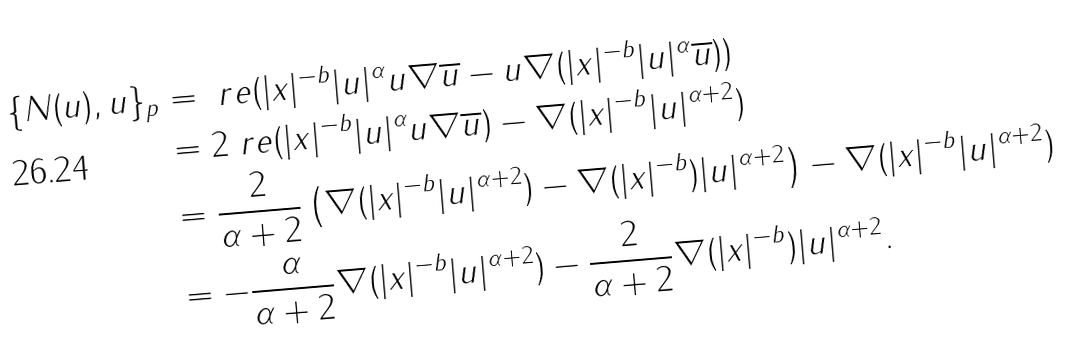<formula> <loc_0><loc_0><loc_500><loc_500>\{ N ( u ) , u \} _ { p } & = \ r e { ( | x | ^ { - b } | u | ^ { \alpha } u \nabla \overline { u } - u \nabla ( | x | ^ { - b } | u | ^ { \alpha } \overline { u } ) ) } \\ & = 2 \ r e { ( | x | ^ { - b } | u | ^ { \alpha } u \nabla \overline { u } ) } - \nabla ( | x | ^ { - b } | u | ^ { \alpha + 2 } ) \\ & = \frac { 2 } { \alpha + 2 } \left ( \nabla ( | x | ^ { - b } | u | ^ { \alpha + 2 } ) - \nabla ( | x | ^ { - b } ) | u | ^ { \alpha + 2 } \right ) - \nabla ( | x | ^ { - b } | u | ^ { \alpha + 2 } ) \\ & = - \frac { \alpha } { \alpha + 2 } \nabla ( | x | ^ { - b } | u | ^ { \alpha + 2 } ) - \frac { 2 } { \alpha + 2 } \nabla ( | x | ^ { - b } ) | u | ^ { \alpha + 2 } .</formula> 